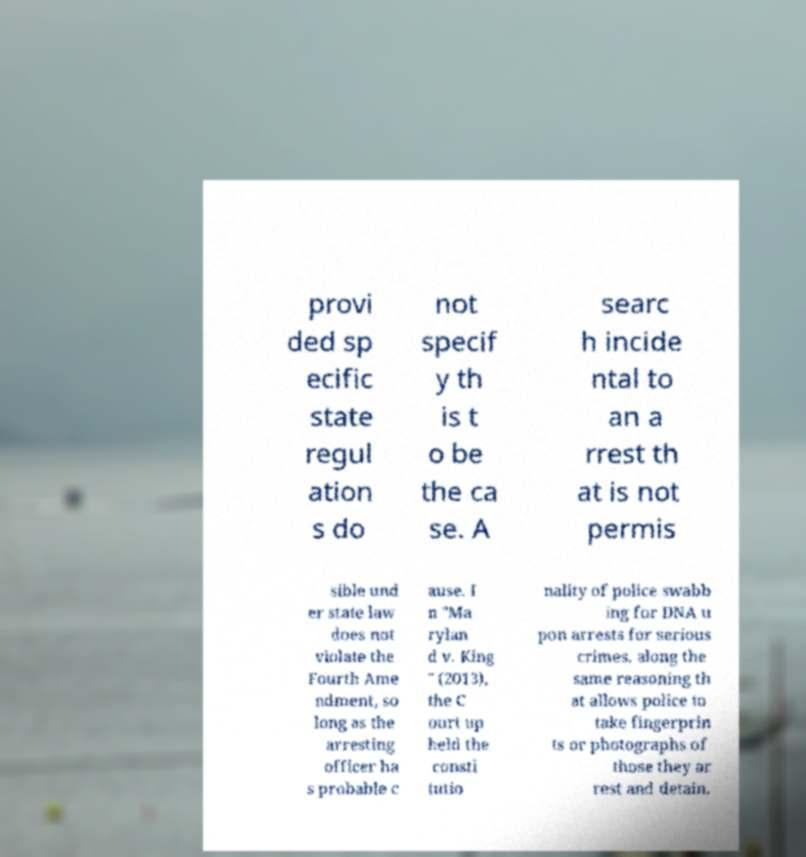Could you extract and type out the text from this image? provi ded sp ecific state regul ation s do not specif y th is t o be the ca se. A searc h incide ntal to an a rrest th at is not permis sible und er state law does not violate the Fourth Ame ndment, so long as the arresting officer ha s probable c ause. I n "Ma rylan d v. King " (2013), the C ourt up held the consti tutio nality of police swabb ing for DNA u pon arrests for serious crimes, along the same reasoning th at allows police to take fingerprin ts or photographs of those they ar rest and detain. 